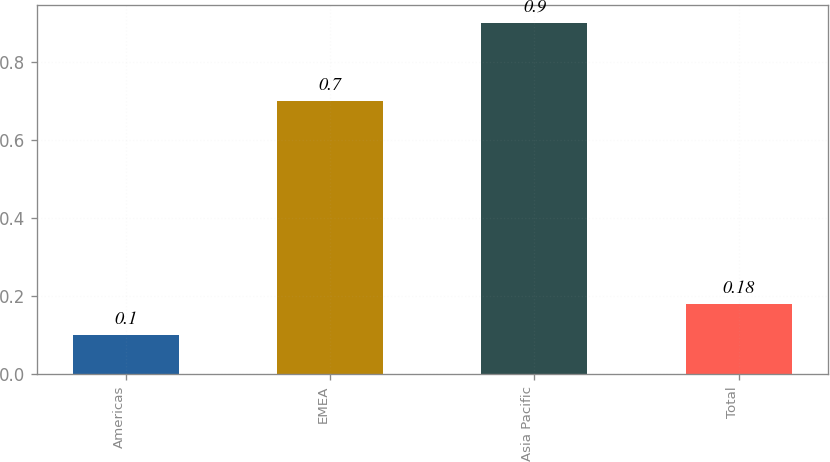Convert chart to OTSL. <chart><loc_0><loc_0><loc_500><loc_500><bar_chart><fcel>Americas<fcel>EMEA<fcel>Asia Pacific<fcel>Total<nl><fcel>0.1<fcel>0.7<fcel>0.9<fcel>0.18<nl></chart> 